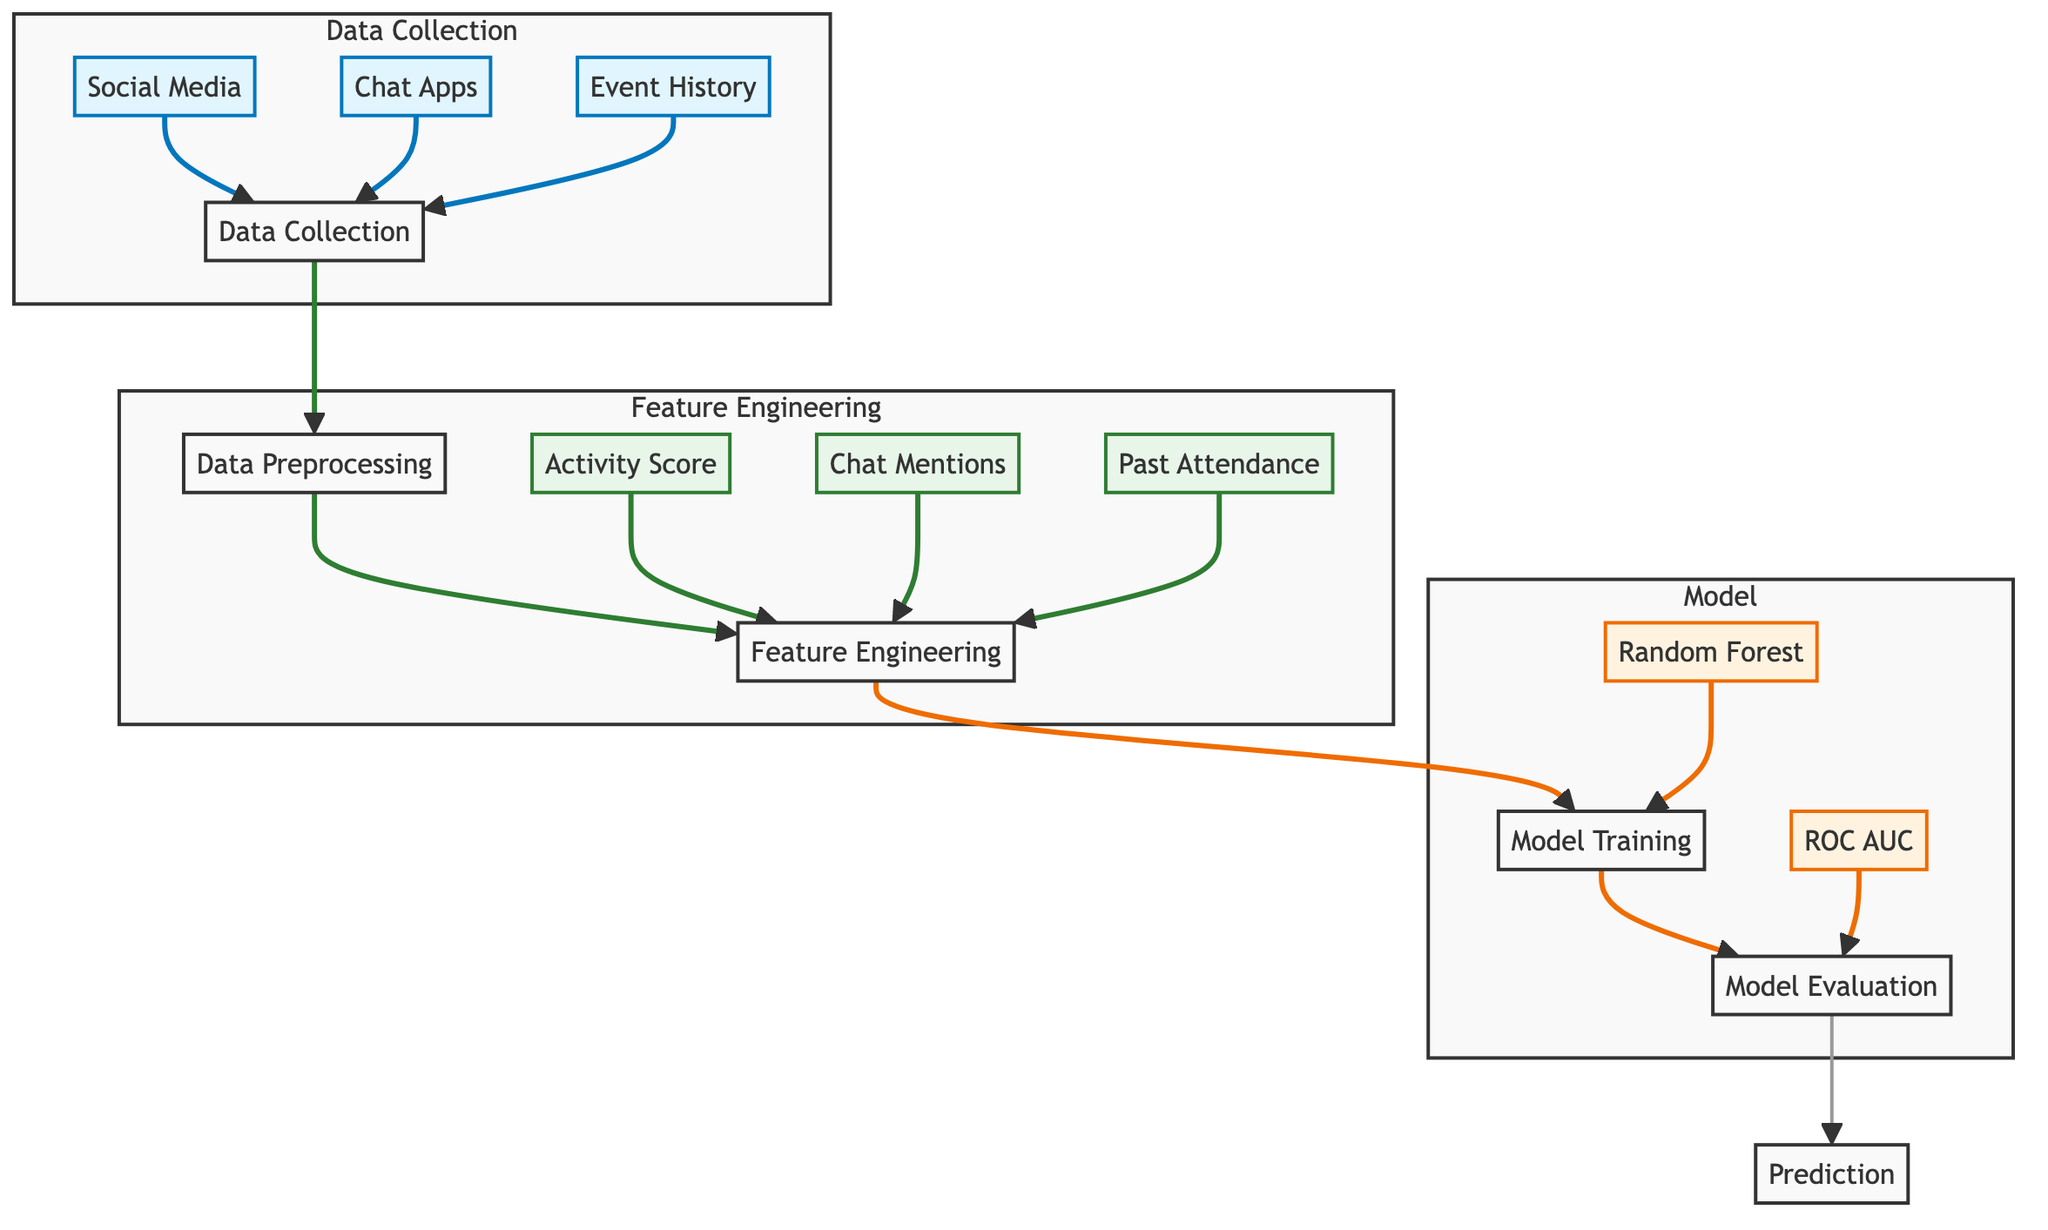What are the sources of data in the diagram? In the diagram, the sources of data are indicated by three nodes: Social Media, Chat Apps, and Event History. These nodes are connected to the Data Collection node, showing that they are integral sources for gathering data.
Answer: Social Media, Chat Apps, Event History How many nodes are there in the Model subgraph? The Model subgraph includes four nodes: Model Training, Random Forest, Model Evaluation, and ROC AUC. Counting these nodes gives us a total of four within that specific subgraph.
Answer: Four What is the first step after Data Collection? The first step following Data Collection in the diagram is Data Preprocessing, which is connected directly to the Data Collection node. This indicates that data processing occurs immediately after data is collected.
Answer: Data Preprocessing How many feature nodes are present in the diagram? The diagram features three nodes in the Feature Engineering subgraph: Activity Score, Chat Mentions, and Past Attendance. Totaling these nodes gives us a count of three feature nodes.
Answer: Three What is the output of the Model Evaluation? The output of Model Evaluation is connected to the Prediction node, which means that the result of evaluating the model is used to generate predictions regarding friends' participation in social events.
Answer: Prediction What training method is depicted in the Model section? The training method depicted in the Model section is Random Forest, shown as a node within the Model subgraph indicating the specific algorithm utilized for training the predictive model.
Answer: Random Forest Which step follows Feature Engineering? The step that follows Feature Engineering is Model Training, as indicated by the direct connection from the Feature Engineering node to the Model Training node in the diagram.
Answer: Model Training What performance metric is used for evaluation in the model? The performance metric used for evaluation in the model is ROC AUC, which is represented as a node in the Model subgraph connected to Model Evaluation, implying it measures the model’s effectiveness.
Answer: ROC AUC 